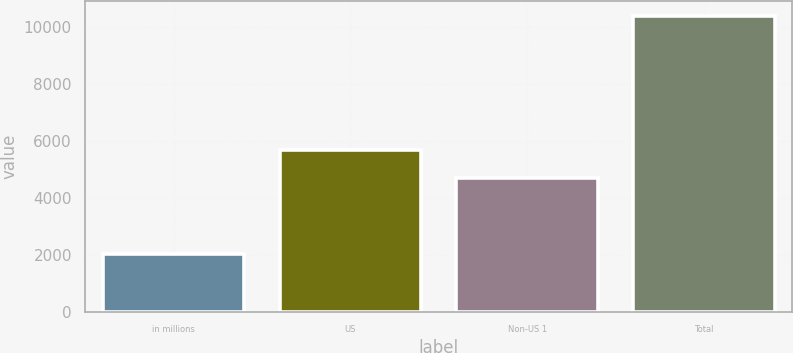<chart> <loc_0><loc_0><loc_500><loc_500><bar_chart><fcel>in millions<fcel>US<fcel>Non-US 1<fcel>Total<nl><fcel>2017<fcel>5686<fcel>4717<fcel>10403<nl></chart> 